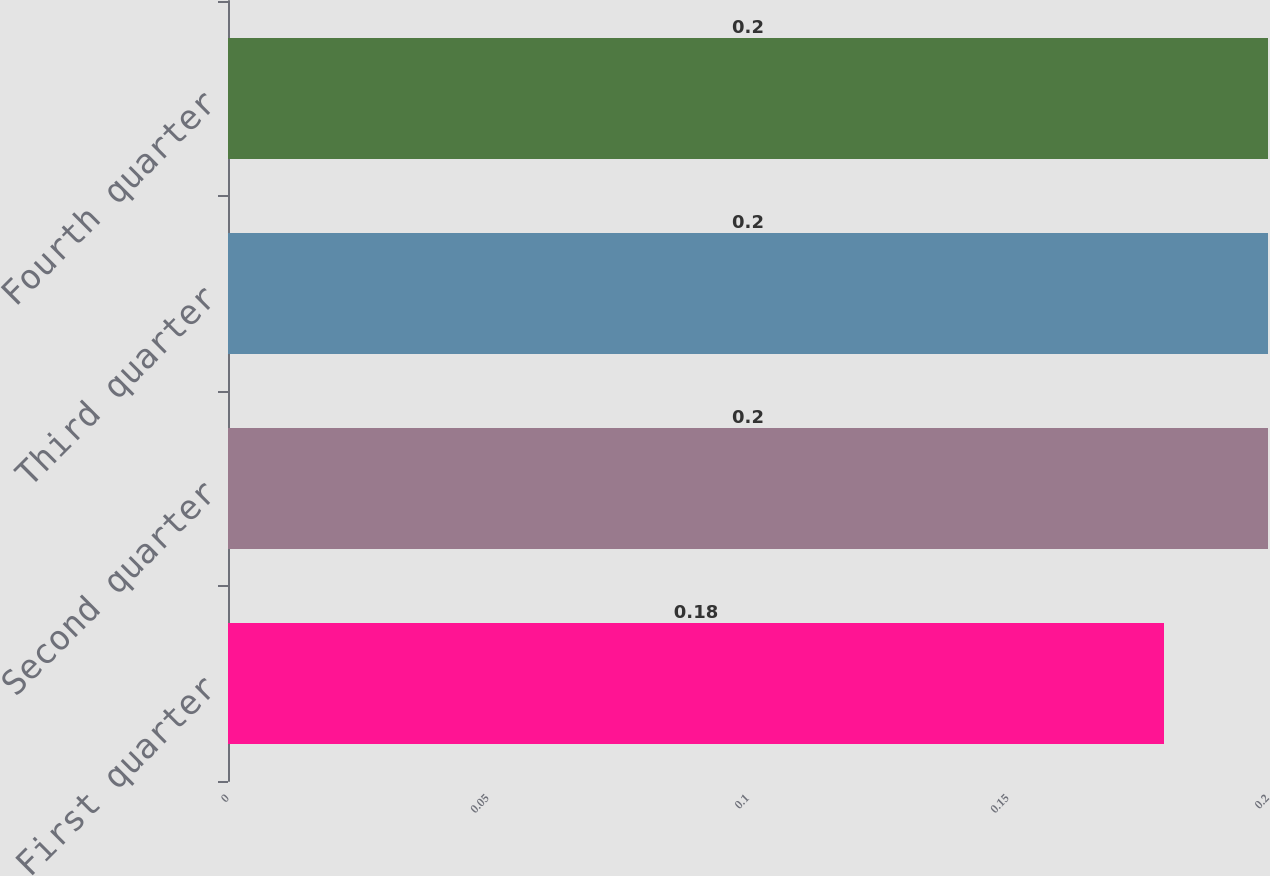<chart> <loc_0><loc_0><loc_500><loc_500><bar_chart><fcel>First quarter<fcel>Second quarter<fcel>Third quarter<fcel>Fourth quarter<nl><fcel>0.18<fcel>0.2<fcel>0.2<fcel>0.2<nl></chart> 